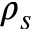<formula> <loc_0><loc_0><loc_500><loc_500>\rho _ { s }</formula> 